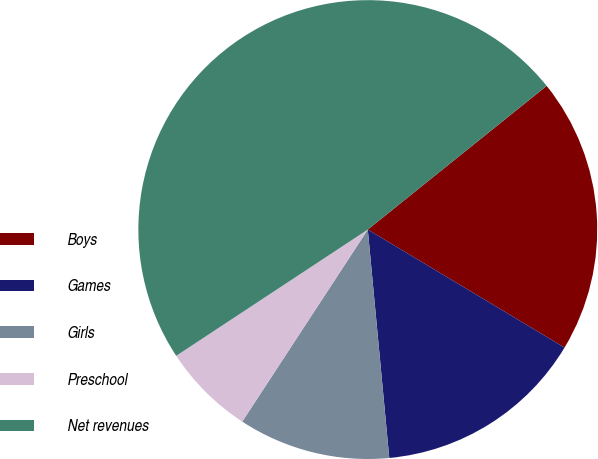<chart> <loc_0><loc_0><loc_500><loc_500><pie_chart><fcel>Boys<fcel>Games<fcel>Girls<fcel>Preschool<fcel>Net revenues<nl><fcel>19.37%<fcel>14.91%<fcel>10.71%<fcel>6.51%<fcel>48.51%<nl></chart> 